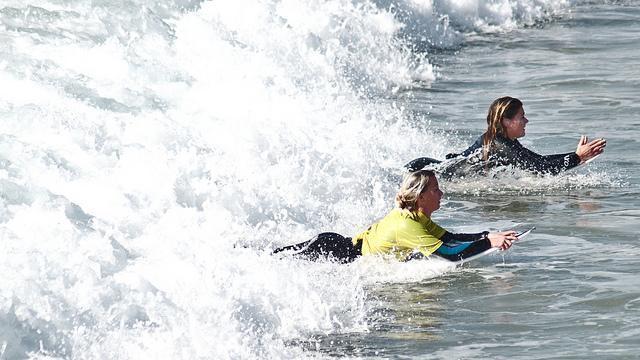What should one be good at before one begins to learn this sport?
Answer the question by selecting the correct answer among the 4 following choices.
Options: Jumping, flipping, dancing, swimming. Swimming. 